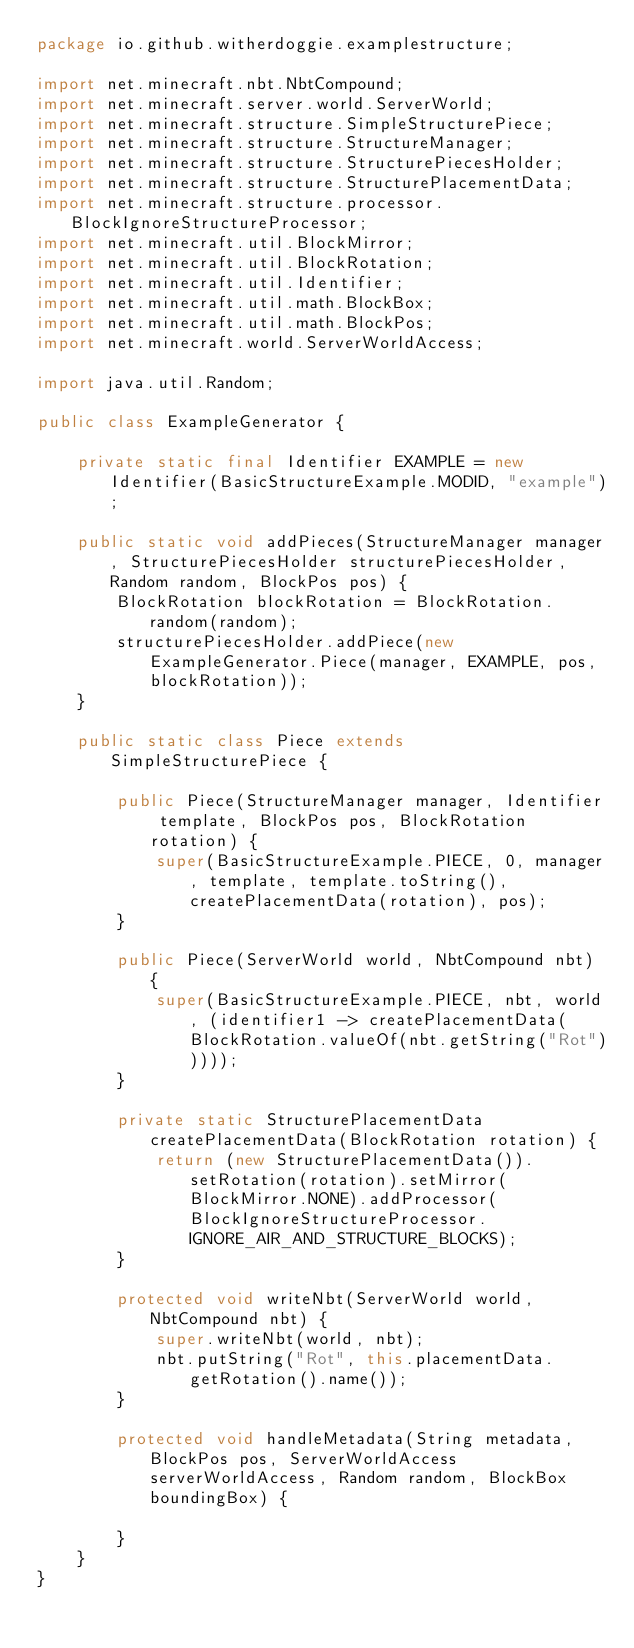<code> <loc_0><loc_0><loc_500><loc_500><_Java_>package io.github.witherdoggie.examplestructure;

import net.minecraft.nbt.NbtCompound;
import net.minecraft.server.world.ServerWorld;
import net.minecraft.structure.SimpleStructurePiece;
import net.minecraft.structure.StructureManager;
import net.minecraft.structure.StructurePiecesHolder;
import net.minecraft.structure.StructurePlacementData;
import net.minecraft.structure.processor.BlockIgnoreStructureProcessor;
import net.minecraft.util.BlockMirror;
import net.minecraft.util.BlockRotation;
import net.minecraft.util.Identifier;
import net.minecraft.util.math.BlockBox;
import net.minecraft.util.math.BlockPos;
import net.minecraft.world.ServerWorldAccess;

import java.util.Random;

public class ExampleGenerator {

    private static final Identifier EXAMPLE = new Identifier(BasicStructureExample.MODID, "example");

    public static void addPieces(StructureManager manager, StructurePiecesHolder structurePiecesHolder, Random random, BlockPos pos) {
        BlockRotation blockRotation = BlockRotation.random(random);
        structurePiecesHolder.addPiece(new ExampleGenerator.Piece(manager, EXAMPLE, pos, blockRotation));
    }

    public static class Piece extends SimpleStructurePiece {

        public Piece(StructureManager manager, Identifier template, BlockPos pos, BlockRotation rotation) {
            super(BasicStructureExample.PIECE, 0, manager, template, template.toString(), createPlacementData(rotation), pos);
        }

        public Piece(ServerWorld world, NbtCompound nbt) {
            super(BasicStructureExample.PIECE, nbt, world, (identifier1 -> createPlacementData(BlockRotation.valueOf(nbt.getString("Rot")))));
        }

        private static StructurePlacementData createPlacementData(BlockRotation rotation) {
            return (new StructurePlacementData()).setRotation(rotation).setMirror(BlockMirror.NONE).addProcessor(BlockIgnoreStructureProcessor.IGNORE_AIR_AND_STRUCTURE_BLOCKS);
        }

        protected void writeNbt(ServerWorld world, NbtCompound nbt) {
            super.writeNbt(world, nbt);
            nbt.putString("Rot", this.placementData.getRotation().name());
        }

        protected void handleMetadata(String metadata, BlockPos pos, ServerWorldAccess serverWorldAccess, Random random, BlockBox boundingBox) {

        }
    }
}
</code> 